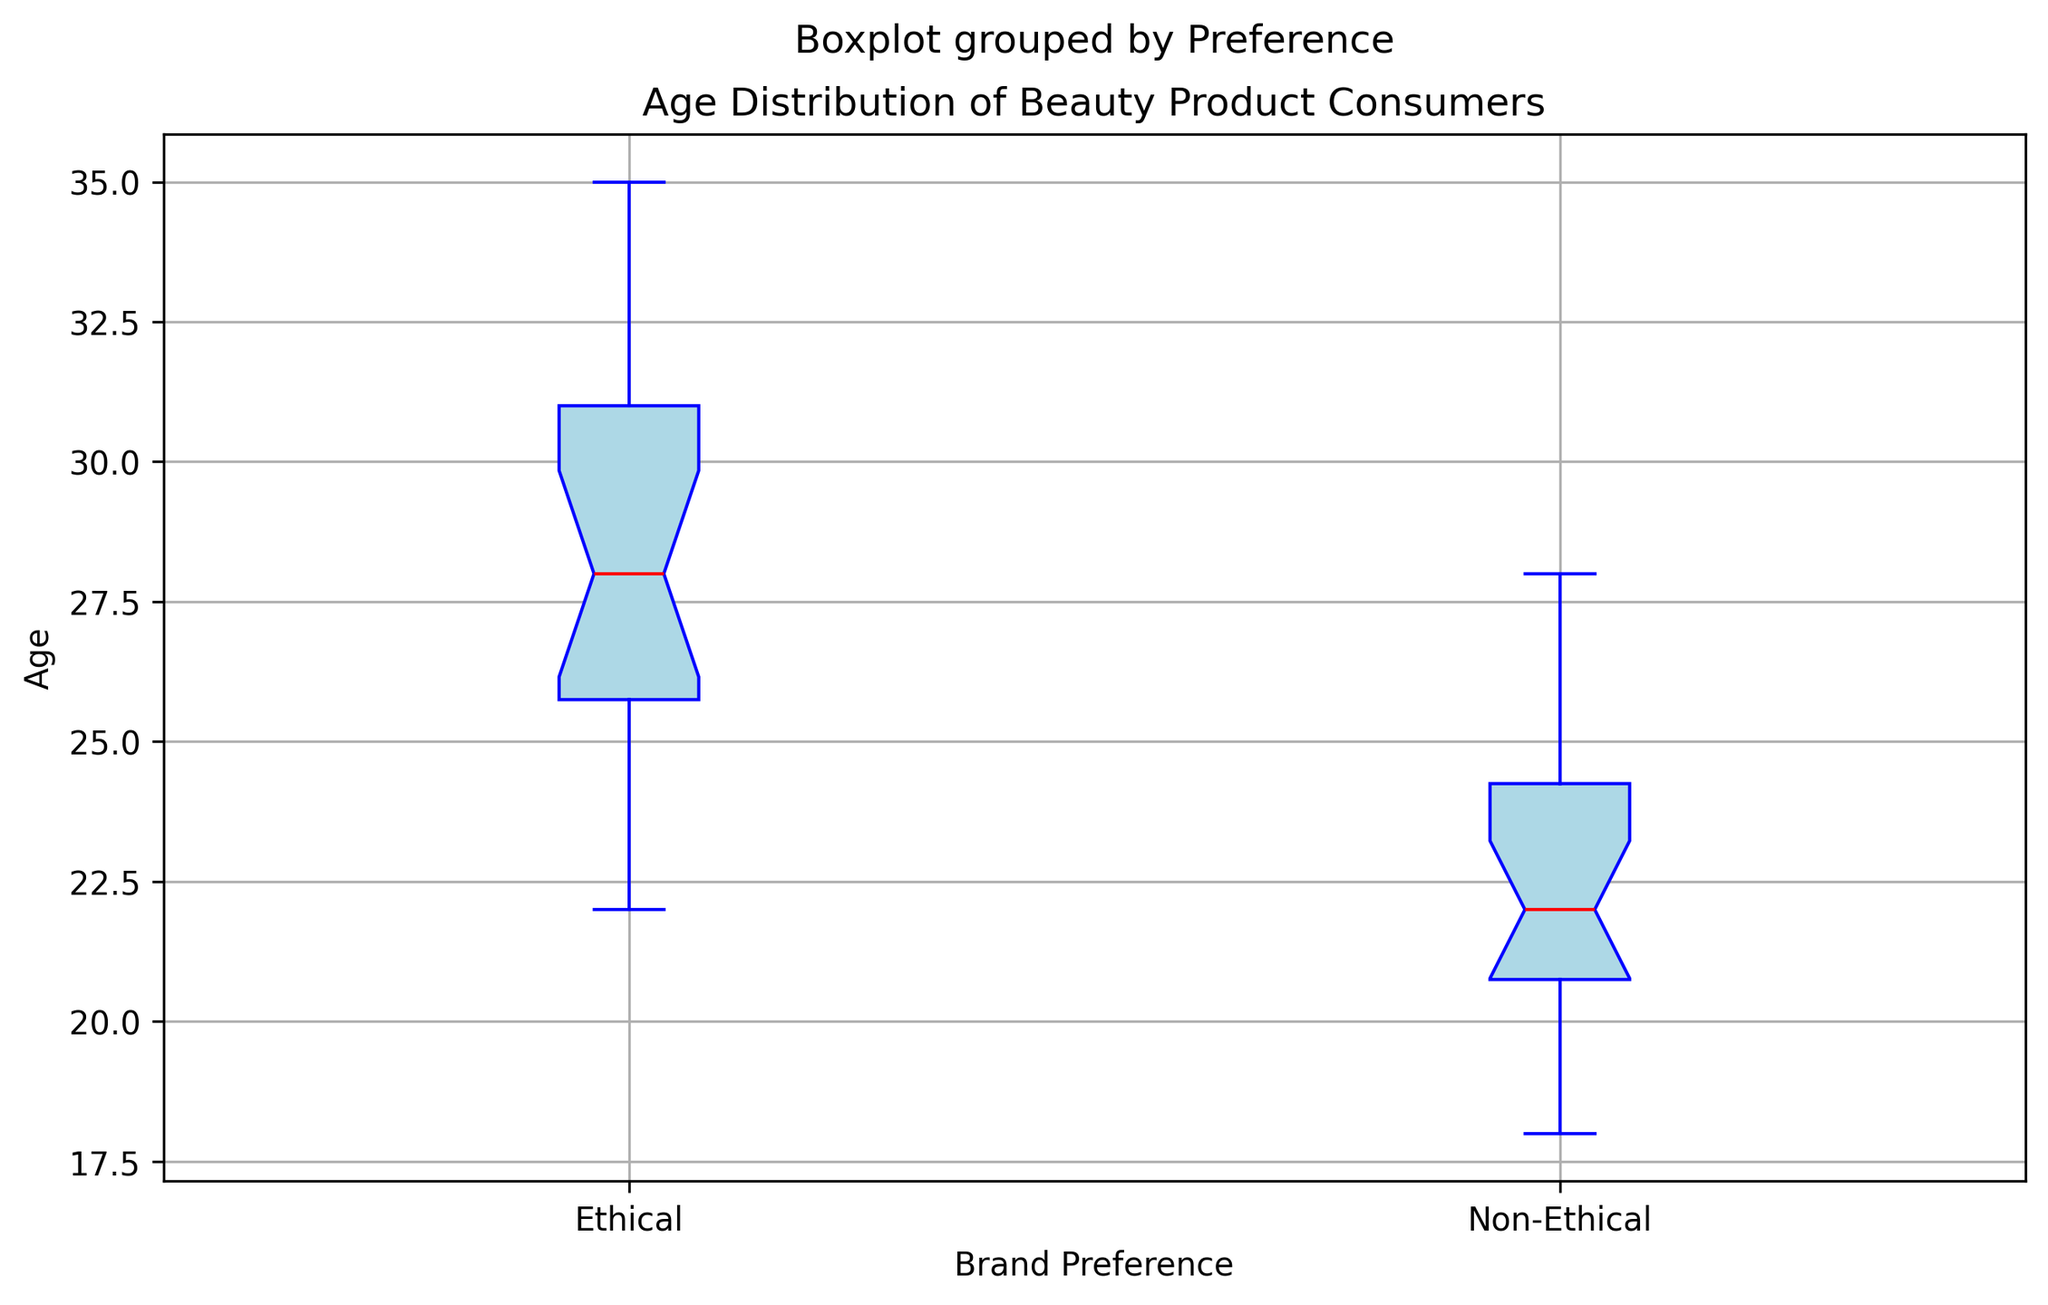Which group has the higher median age? The median age is represented by the horizontal line within the box of each box plot. The position of the red line in the Ethical preference box is higher than in the Non-Ethical box.
Answer: Ethical What is the age range (difference between the oldest and youngest) for consumers preferring non-ethical brands? The age range is determined by the difference between the highest whisker and the lowest whisker. For Non-Ethical, the maximum is 28 and the minimum is 18, so the range is 28 - 18 = 10.
Answer: 10 How do the interquartile ranges (IQR) compare between the two groups? The IQR can be found by identifying the difference between the 75th percentile (upper edge of the box) and the 25th percentile (lower edge of the box). The IQR for Ethical looks larger than the IQR for Non-Ethical.
Answer: Ethical IQR > Non-Ethical IQR What is the median age of consumers who prefer ethical brands? The median age is represented by the horizontal red line inside the box plot for the Ethical group. The median appears to be around 27-28.
Answer: ~28 Which group has a higher maximum age value? The highest whisker represents the maximum age value. The highest whisker in the Ethical preference box plot extends to a greater age than the Non-Ethical preference box plot.
Answer: Ethical How do the lowest ages (minimum values) for the two groups compare? The lowest whisker represents the minimum age in each group. The minimum value for Non-Ethical is lower than for Ethical.
Answer: Non-Ethical < Ethical What is the median difference in age between the consumers of ethical and non-ethical brands? Refer to the median values of both groups: Ethical has a median around 28 and Non-Ethical around 22. The difference is 28 - 22 = 6.
Answer: 6 Which group has more dispersion in ages? Dispersion can be identified by the length of the box and whiskers. The Ethical group has longer box and whiskers, indicating more dispersion.
Answer: Ethical What color represents the median in both box plots? The median line in both box plots is represented in red color.
Answer: Red Is there any overlap in the interquartile ranges (IQR) of the two groups? The upper quartile (75th percentile) of Non-Ethical is lower than the lower quartile (25th percentile) of Ethical. Thus, there is no overlap in their IQRs.
Answer: No 